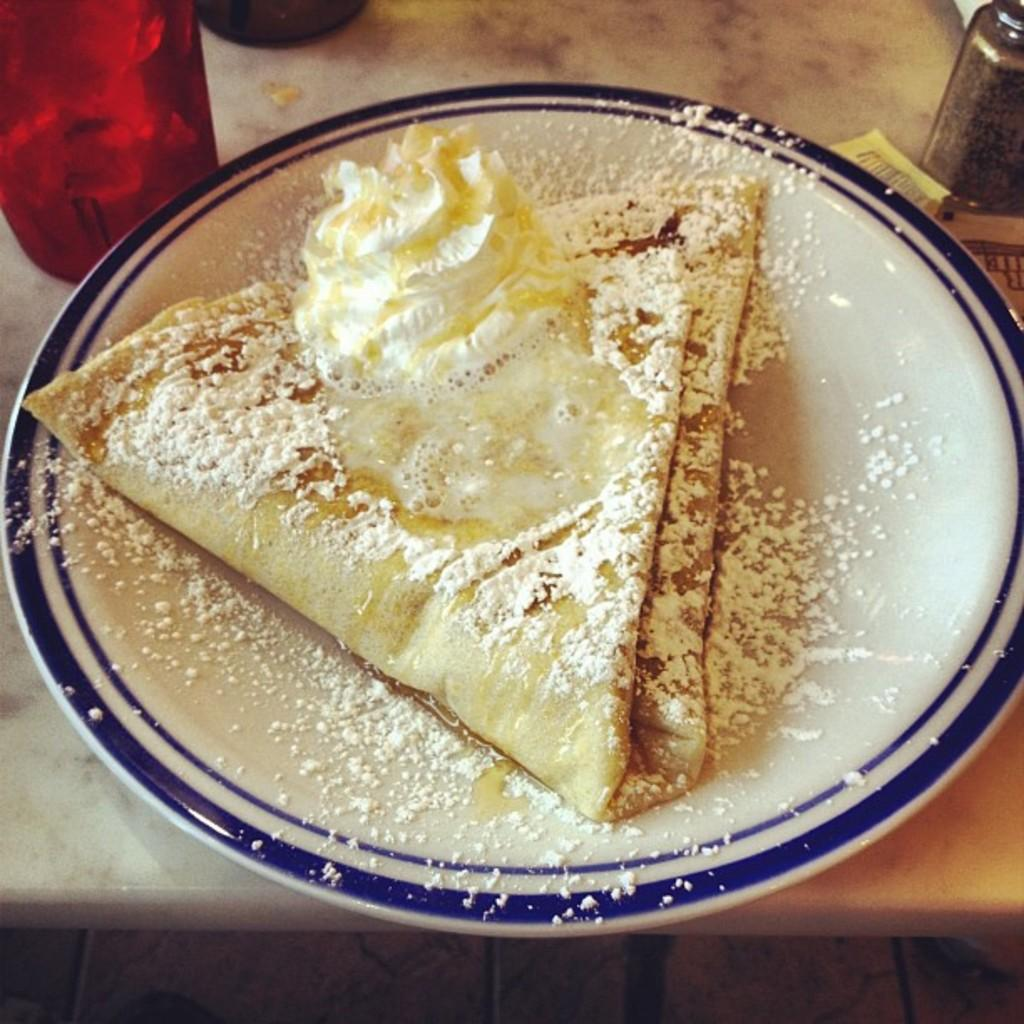What is at the bottom of the image? There is a floor at the bottom of the image. What can be seen in the left corner of the image? There is a red colored object in the left corner of the image. What is in the right corner of the image? There is an object in the right corner of the image. What is on the table in the image? There is a plate with food on a table in the image. What type of disease is affecting the territory in the image? There is no mention of a territory or disease in the image; it only contains a floor, a red object, an object in the right corner, and a plate with food on a table. 